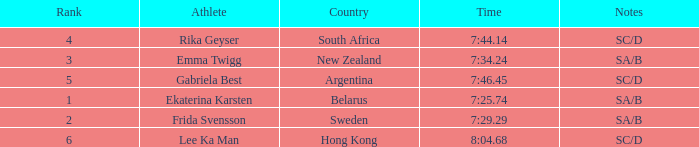What is the time of frida svensson's race that had sa/b under the notes? 7:29.29. 